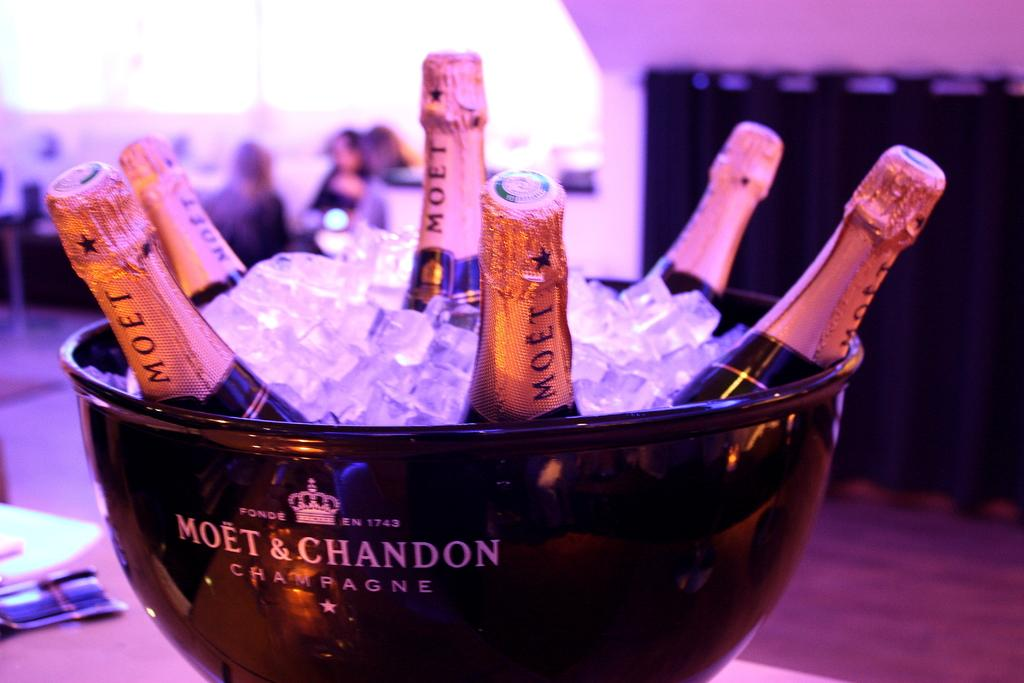Provide a one-sentence caption for the provided image. A bucket that says Moet & Chandon full of ice and with 6 Merlot bottles of wine in it. 